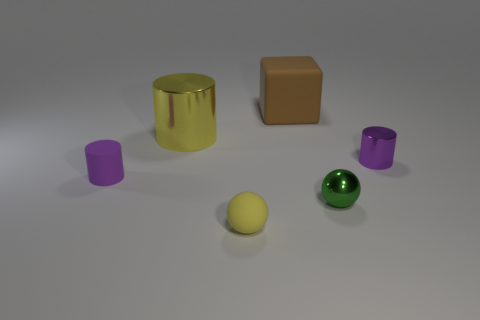What number of other things are there of the same size as the yellow sphere?
Your answer should be very brief. 3. There is a shiny thing behind the purple cylinder behind the small purple matte object; what is its color?
Your answer should be very brief. Yellow. How many other objects are there of the same shape as the tiny yellow object?
Give a very brief answer. 1. Are there any blocks made of the same material as the brown object?
Your answer should be very brief. No. There is a object that is the same size as the yellow shiny cylinder; what material is it?
Ensure brevity in your answer.  Rubber. What is the color of the cube that is behind the tiny cylinder that is on the left side of the small purple object that is right of the metallic sphere?
Ensure brevity in your answer.  Brown. Does the small purple object to the right of the big brown thing have the same shape as the matte object that is behind the small purple rubber thing?
Ensure brevity in your answer.  No. What number of large yellow metal blocks are there?
Provide a succinct answer. 0. What is the color of the other cylinder that is the same size as the purple metallic cylinder?
Your answer should be very brief. Purple. Is the small purple thing that is to the right of the purple rubber thing made of the same material as the small purple cylinder that is left of the big yellow thing?
Offer a terse response. No. 